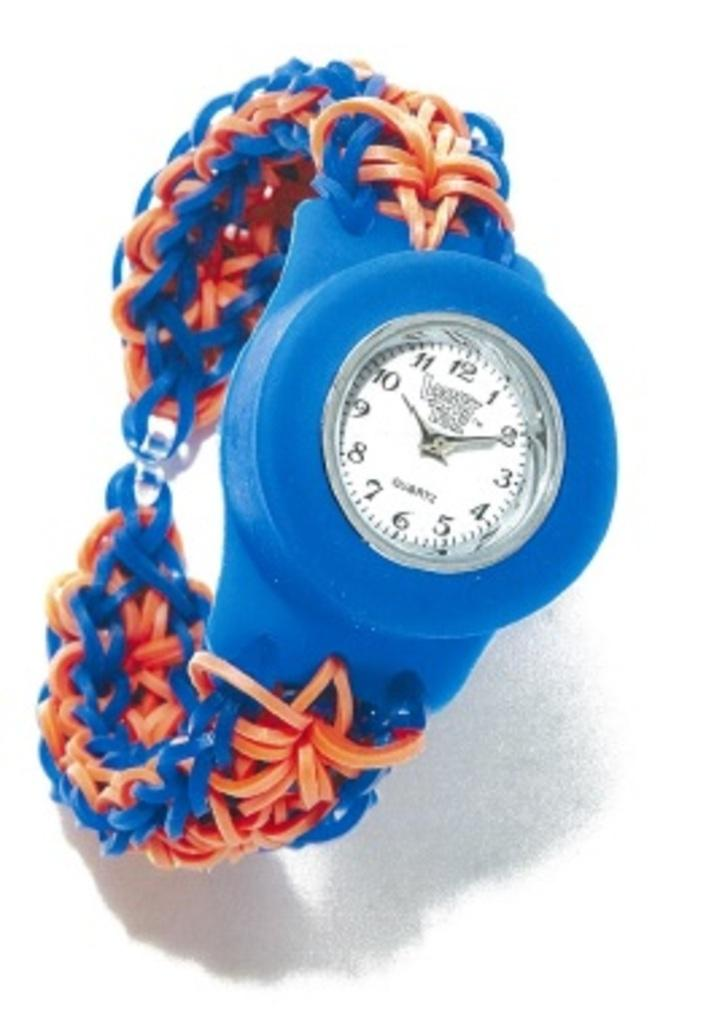<image>
Give a short and clear explanation of the subsequent image. A blue and orange children's watch states that it;s 10:10. 